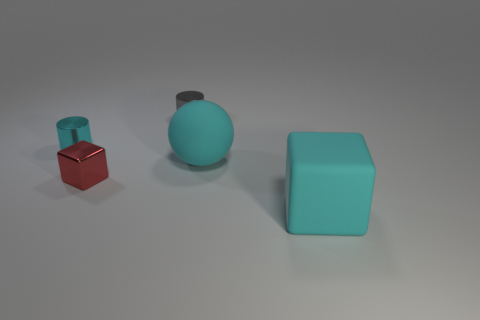Is the color of the rubber block the same as the matte thing behind the tiny red object?
Offer a very short reply. Yes. Are there fewer small gray shiny balls than shiny cubes?
Provide a succinct answer. Yes. There is a thing that is to the left of the gray metallic object and in front of the cyan metallic object; what is its size?
Ensure brevity in your answer.  Small. There is a rubber object that is to the right of the big cyan sphere; is its color the same as the big sphere?
Your answer should be compact. Yes. Are there fewer large cyan matte blocks that are on the right side of the big cyan rubber cube than red objects?
Ensure brevity in your answer.  Yes. The cyan object that is the same material as the large block is what shape?
Provide a short and direct response. Sphere. Is the material of the cyan block the same as the tiny cube?
Your response must be concise. No. Is the number of cyan balls behind the tiny gray cylinder less than the number of gray cylinders that are to the left of the cyan cube?
Your answer should be compact. Yes. The cylinder that is the same color as the ball is what size?
Ensure brevity in your answer.  Small. There is a big cyan object that is to the left of the cube that is to the right of the rubber sphere; how many big cyan matte blocks are right of it?
Make the answer very short. 1. 